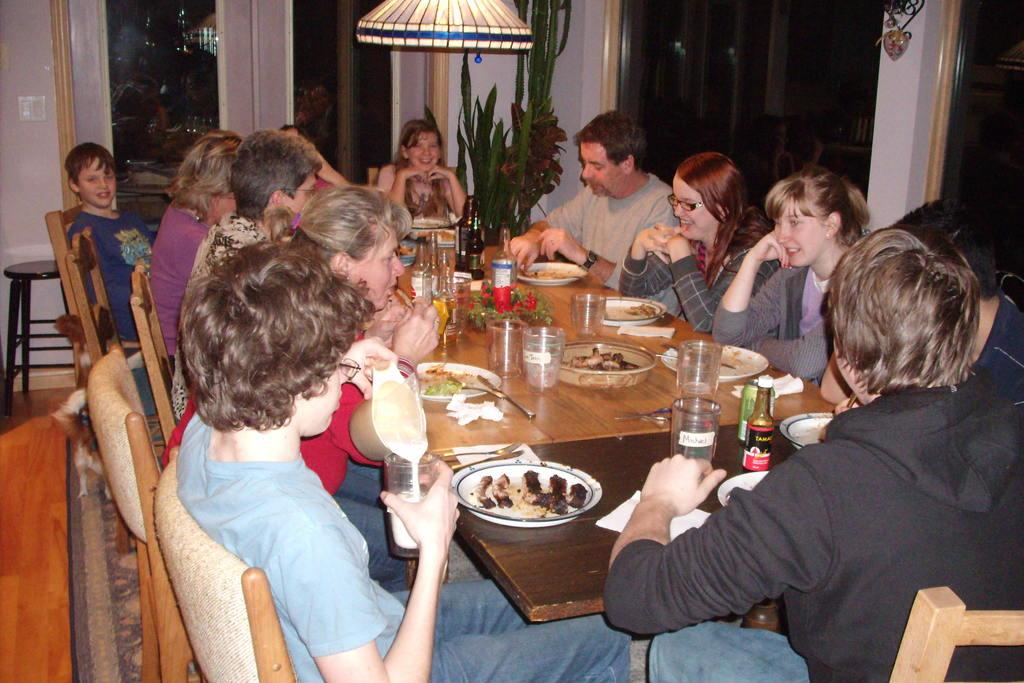Who or what is present in the image? There are people in the image. What are the people doing in the image? The people are sitting on chairs. How are the chairs arranged in the image? The chairs are arranged around a table. What can be found on the table in the image? There are food items on the table. Can you see any visible veins on the tomatoes in the image? There are no tomatoes present in the image, so it is not possible to see any veins on them. 